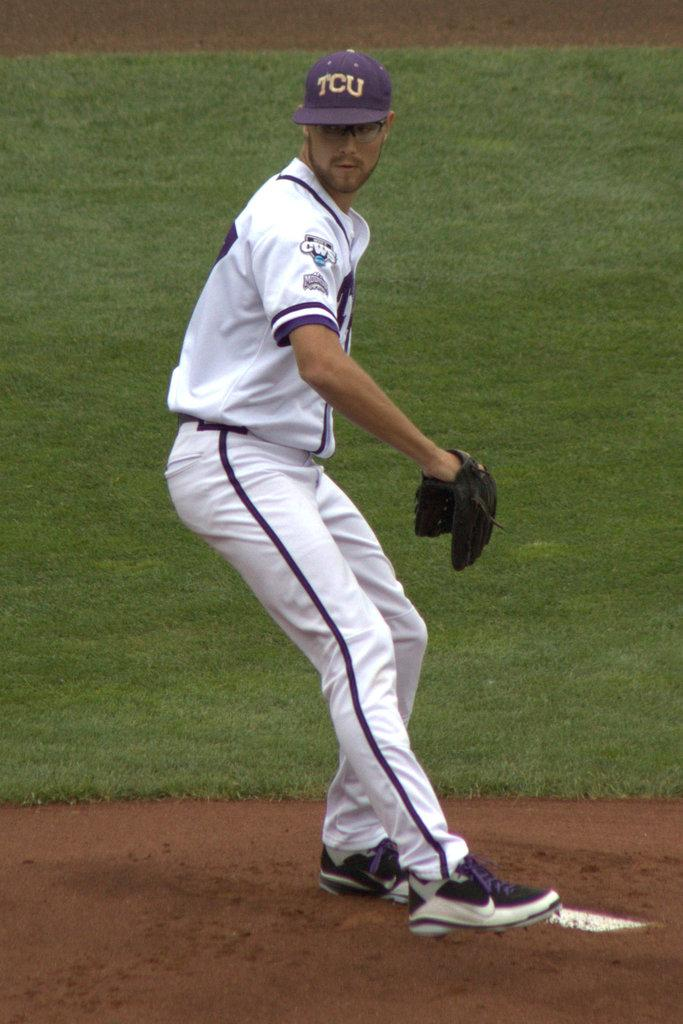<image>
Provide a brief description of the given image. A baseball player wearing a cap written TCU on it. 